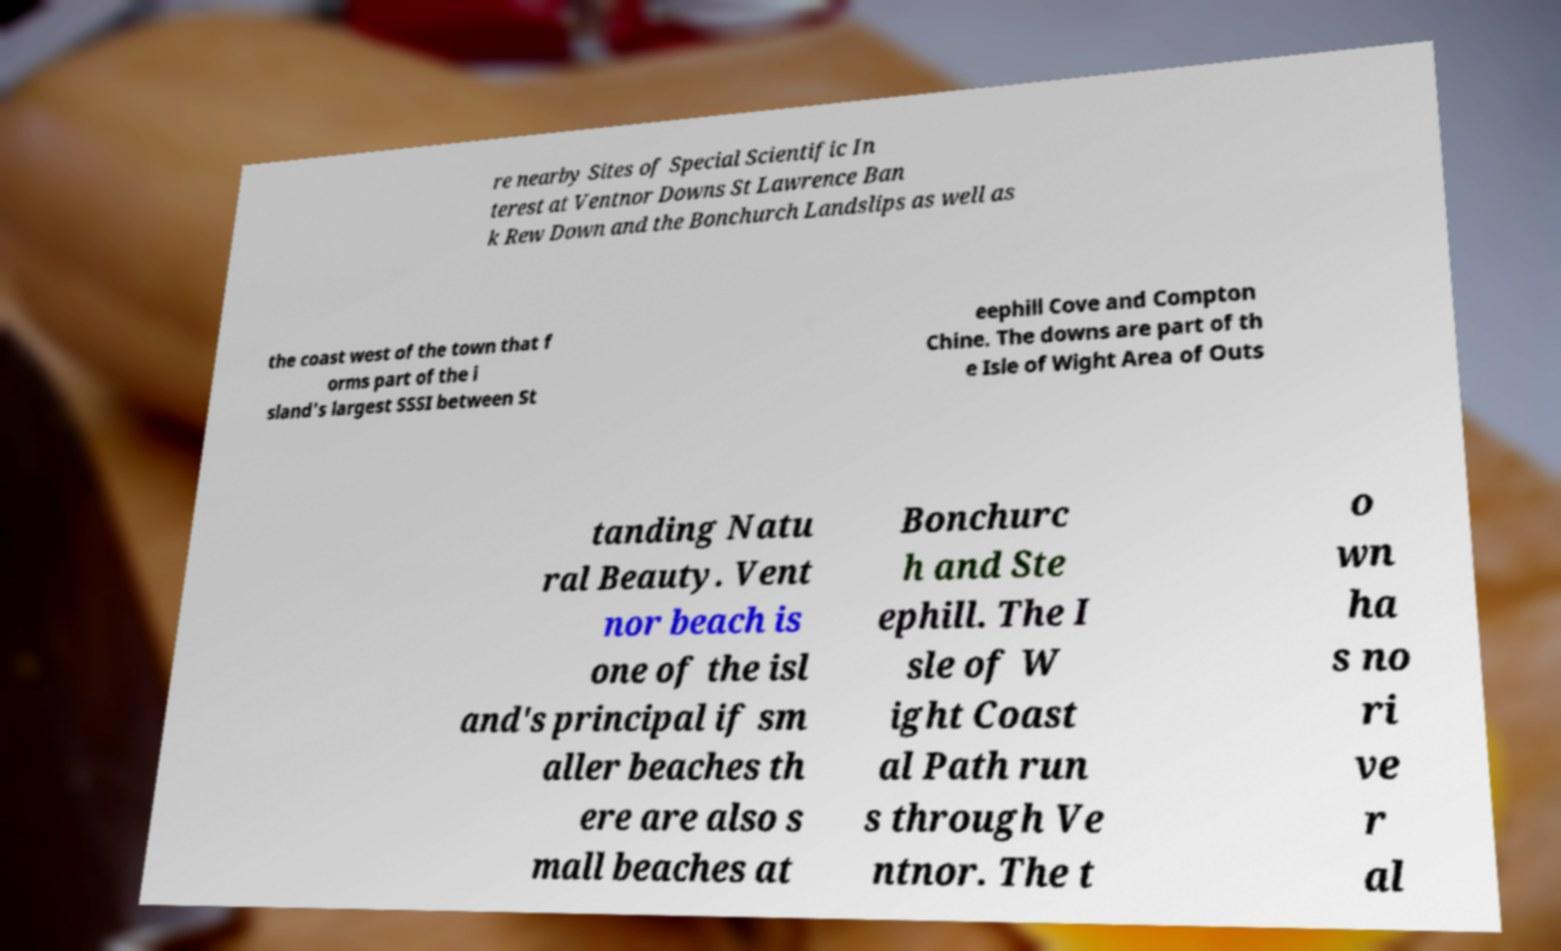For documentation purposes, I need the text within this image transcribed. Could you provide that? re nearby Sites of Special Scientific In terest at Ventnor Downs St Lawrence Ban k Rew Down and the Bonchurch Landslips as well as the coast west of the town that f orms part of the i sland's largest SSSI between St eephill Cove and Compton Chine. The downs are part of th e Isle of Wight Area of Outs tanding Natu ral Beauty. Vent nor beach is one of the isl and's principal if sm aller beaches th ere are also s mall beaches at Bonchurc h and Ste ephill. The I sle of W ight Coast al Path run s through Ve ntnor. The t o wn ha s no ri ve r al 